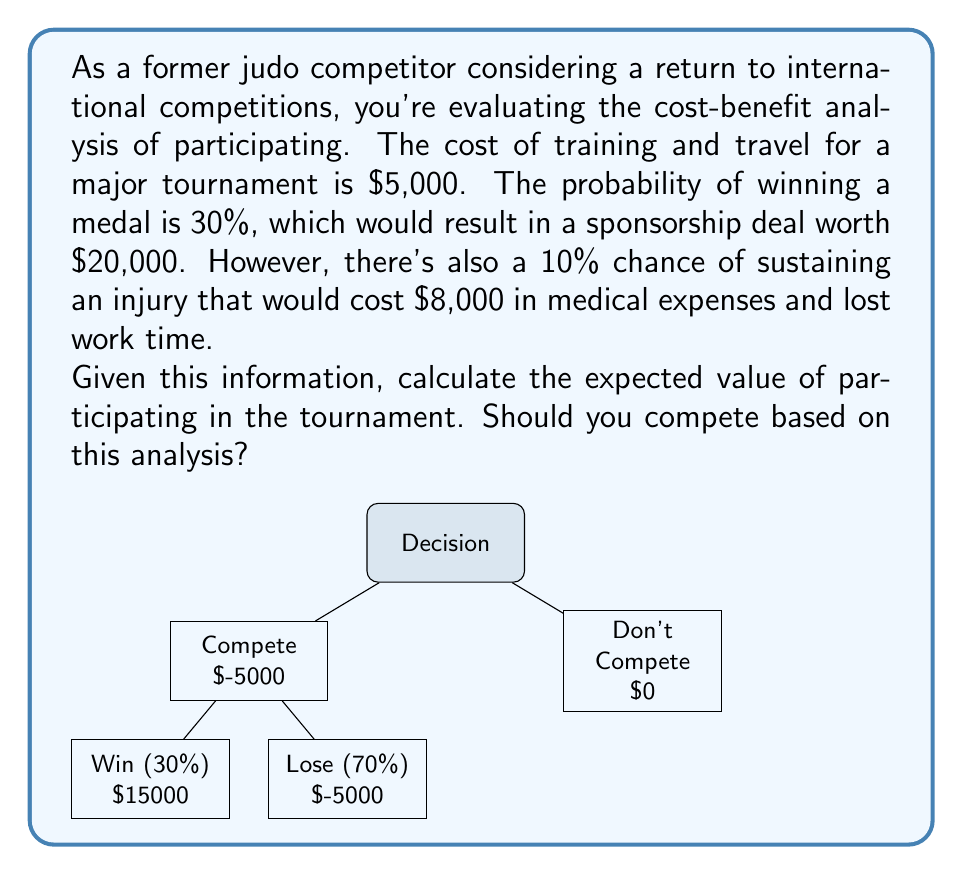Help me with this question. Let's break this down step-by-step:

1) First, we need to calculate the expected value of competing. The expected value is the sum of each possible outcome multiplied by its probability.

2) There are three possible outcomes:
   a) Win a medal (30% chance)
   b) Lose without injury (60% chance)
   c) Lose with injury (10% chance)

3) Let's calculate the value of each outcome:
   a) Win: $20,000 (sponsorship) - $5,000 (cost) = $15,000
   b) Lose without injury: -$5,000 (cost)
   c) Lose with injury: -$5,000 (cost) - $8,000 (injury expenses) = -$13,000

4) Now, let's calculate the expected value:
   $$ EV = (0.30 \times 15000) + (0.60 \times -5000) + (0.10 \times -13000) $$

5) Simplifying:
   $$ EV = 4500 - 3000 - 1300 = 200 $$

6) The expected value is positive ($200), which means that on average, participating would be profitable.

7) However, this is a relatively small positive value compared to the potential losses. The decision to compete should also consider factors like risk tolerance and non-monetary benefits (e.g., personal satisfaction, maintaining skills).
Answer: $200; Yes, based on positive expected value. 